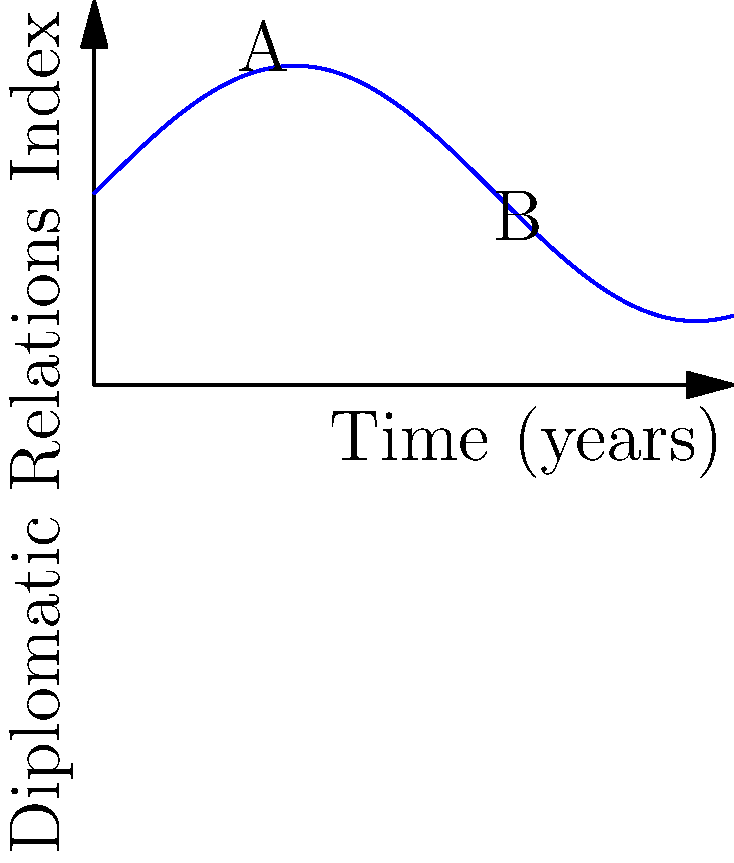The curve represents the Diplomatic Relations Index between the U.S. and Russia over a 10-year period. At point A (2 years), the index is increasing, while at point B (6 years), it is decreasing. If the rate of change at point A is 0.8 units per year and at point B is -0.6 units per year, what is the average rate of change between these two points? To find the average rate of change between points A and B, we need to follow these steps:

1) Identify the coordinates of points A and B:
   A: (2, f(2))
   B: (6, f(6))

2) Calculate the change in the Diplomatic Relations Index (y-axis):
   $\Delta y = f(6) - f(2)$
   We don't have the exact values, but we can use the given information.

3) Calculate the change in time (x-axis):
   $\Delta x = 6 - 2 = 4$ years

4) The average rate of change is given by:
   $\text{Average rate of change} = \frac{\Delta y}{\Delta x}$

5) We can't calculate this directly, but we can use the given instantaneous rates of change:
   At A: 0.8 units/year (increasing)
   At B: -0.6 units/year (decreasing)

6) The average of these two rates will give us a good approximation of the average rate of change:
   $\text{Average rate} = \frac{0.8 + (-0.6)}{2} = \frac{0.2}{2} = 0.1$ units/year

Therefore, the average rate of change between points A and B is approximately 0.1 units per year.
Answer: 0.1 units/year 